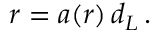<formula> <loc_0><loc_0><loc_500><loc_500>r = a ( r ) \, d _ { L } \, .</formula> 